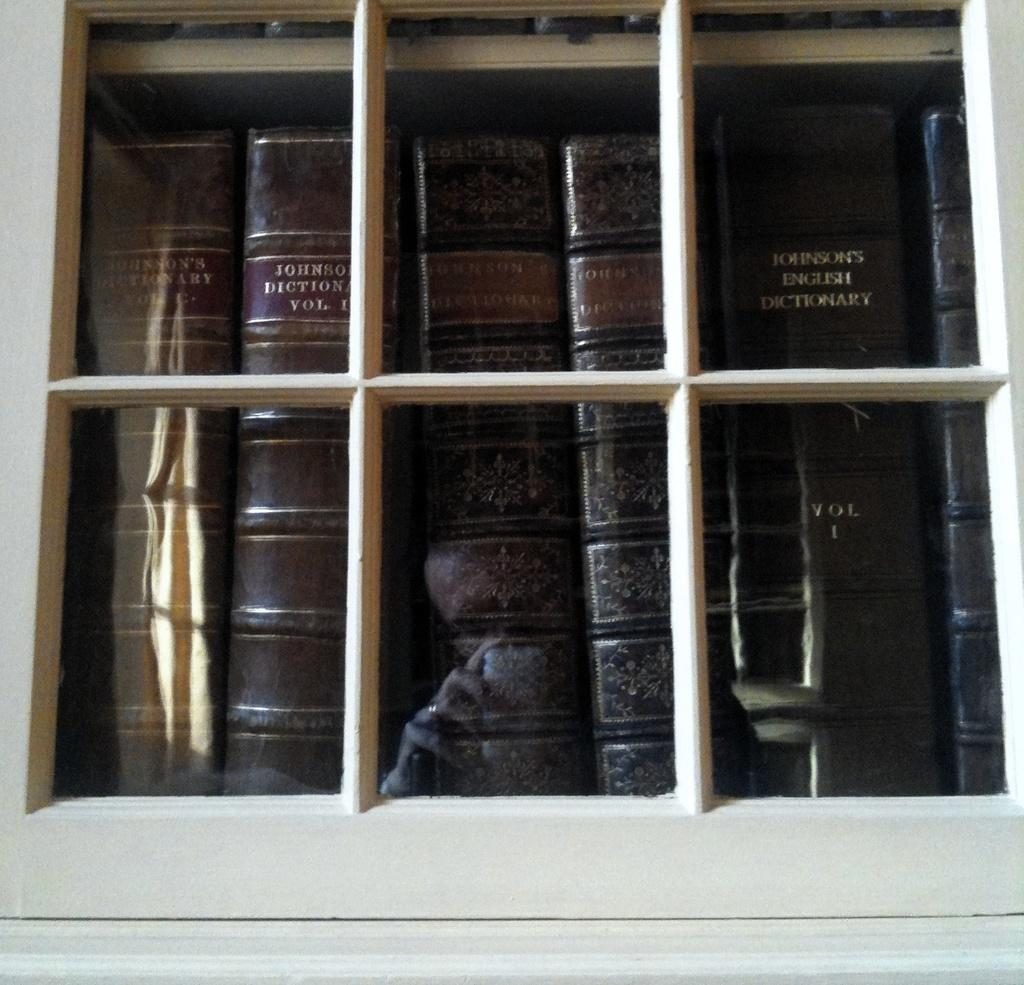<image>
Offer a succinct explanation of the picture presented. the books in the window including Johnson's English Dictionary 